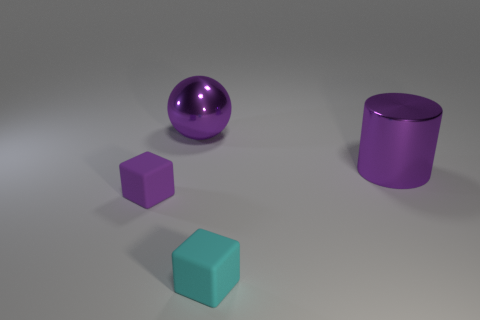What is the material of the small purple object that is the same shape as the tiny cyan matte thing?
Offer a terse response. Rubber. There is a object that is the same material as the purple block; what shape is it?
Provide a short and direct response. Cube. Does the sphere have the same color as the tiny rubber object left of the small cyan rubber cube?
Ensure brevity in your answer.  Yes. What number of cubes are either big shiny objects or small things?
Provide a short and direct response. 2. The tiny object that is in front of the purple rubber object is what color?
Offer a very short reply. Cyan. The tiny thing that is the same color as the large shiny cylinder is what shape?
Keep it short and to the point. Cube. How many purple shiny things have the same size as the purple rubber block?
Keep it short and to the point. 0. Does the big metallic object that is behind the big purple cylinder have the same shape as the purple thing in front of the purple metal cylinder?
Provide a succinct answer. No. The tiny object that is behind the tiny matte thing that is to the right of the tiny cube on the left side of the cyan thing is made of what material?
Provide a succinct answer. Rubber. There is another object that is the same size as the cyan matte thing; what is its shape?
Keep it short and to the point. Cube. 